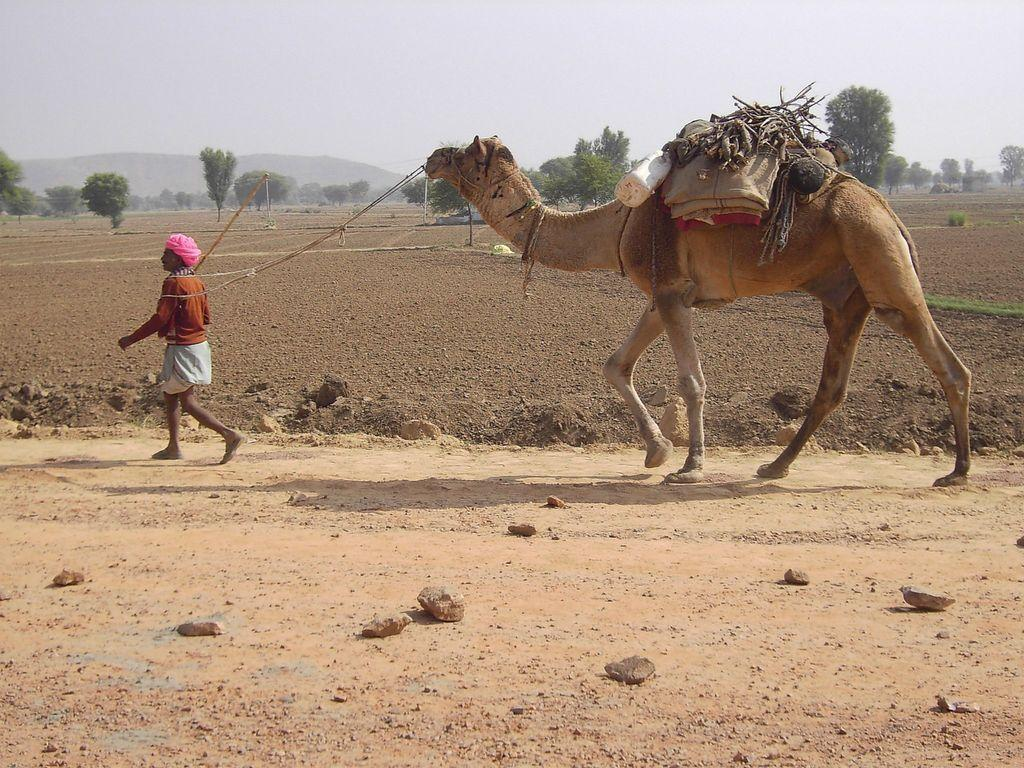Who is present in the image? There is a man in the image. What animal is present in the image? There is a camel in the image. What are the man and camel doing in the image? The man and camel are walking in the image. What can be seen on the ground in the image? There are stones on the ground in the image. What can be seen in the background of the image? There are trees, hills, and the sky visible in the background of the image. What direction is the drain flowing in the image? There is no drain present in the image. What riddle can be solved by looking at the image? There is no riddle associated with the image. 